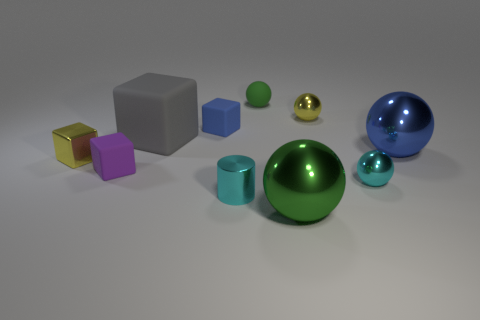Does the small rubber ball have the same color as the small metal cube?
Provide a succinct answer. No. There is a tiny yellow shiny object that is right of the metal sphere that is in front of the small shiny cylinder; how many small cyan shiny things are to the left of it?
Keep it short and to the point. 1. There is a big sphere behind the small sphere in front of the metal cube; what is its color?
Offer a terse response. Blue. What number of other things are there of the same material as the cylinder
Keep it short and to the point. 5. What number of gray objects are behind the cyan shiny object that is on the left side of the small green matte object?
Offer a terse response. 1. Is there any other thing that has the same shape as the big green thing?
Your answer should be very brief. Yes. There is a large metallic ball behind the tiny cyan shiny sphere; is it the same color as the tiny shiny cylinder that is behind the large green object?
Give a very brief answer. No. Are there fewer yellow metallic objects than blue cubes?
Provide a short and direct response. No. What shape is the green object that is in front of the yellow shiny thing on the left side of the blue rubber object?
Your response must be concise. Sphere. Is there any other thing that is the same size as the green rubber sphere?
Provide a short and direct response. Yes. 